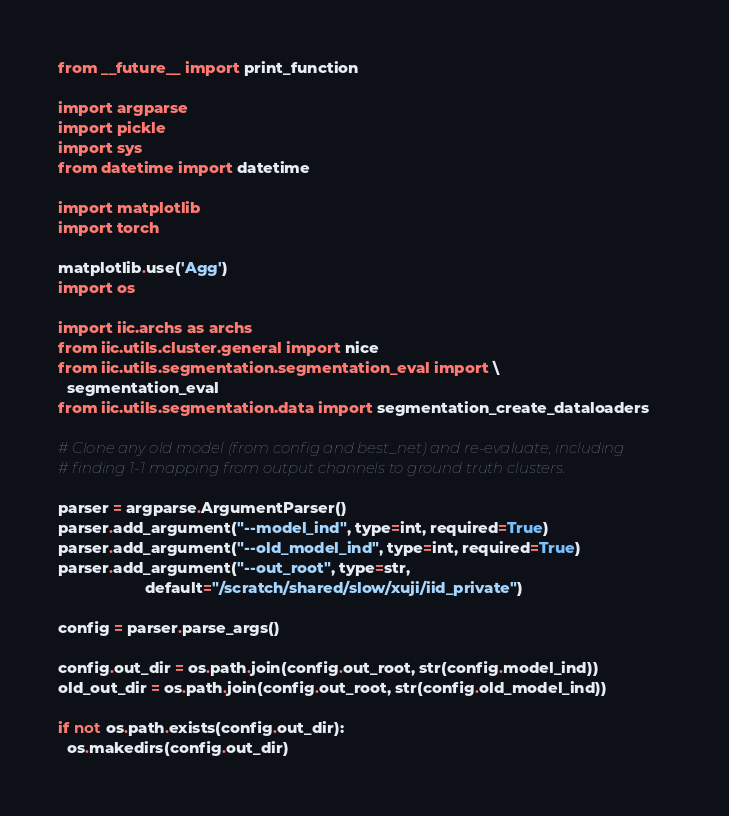<code> <loc_0><loc_0><loc_500><loc_500><_Python_>from __future__ import print_function

import argparse
import pickle
import sys
from datetime import datetime

import matplotlib
import torch

matplotlib.use('Agg')
import os

import iic.archs as archs
from iic.utils.cluster.general import nice
from iic.utils.segmentation.segmentation_eval import \
  segmentation_eval
from iic.utils.segmentation.data import segmentation_create_dataloaders

# Clone any old model (from config and best_net) and re-evaluate, including
# finding 1-1 mapping from output channels to ground truth clusters.

parser = argparse.ArgumentParser()
parser.add_argument("--model_ind", type=int, required=True)
parser.add_argument("--old_model_ind", type=int, required=True)
parser.add_argument("--out_root", type=str,
                    default="/scratch/shared/slow/xuji/iid_private")

config = parser.parse_args()

config.out_dir = os.path.join(config.out_root, str(config.model_ind))
old_out_dir = os.path.join(config.out_root, str(config.old_model_ind))

if not os.path.exists(config.out_dir):
  os.makedirs(config.out_dir)
</code> 